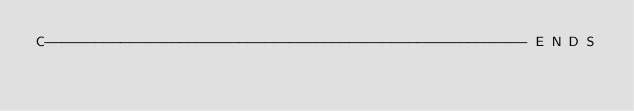Convert code to text. <code><loc_0><loc_0><loc_500><loc_500><_FORTRAN_>C--------------------------------------------------------- E N D S
</code> 